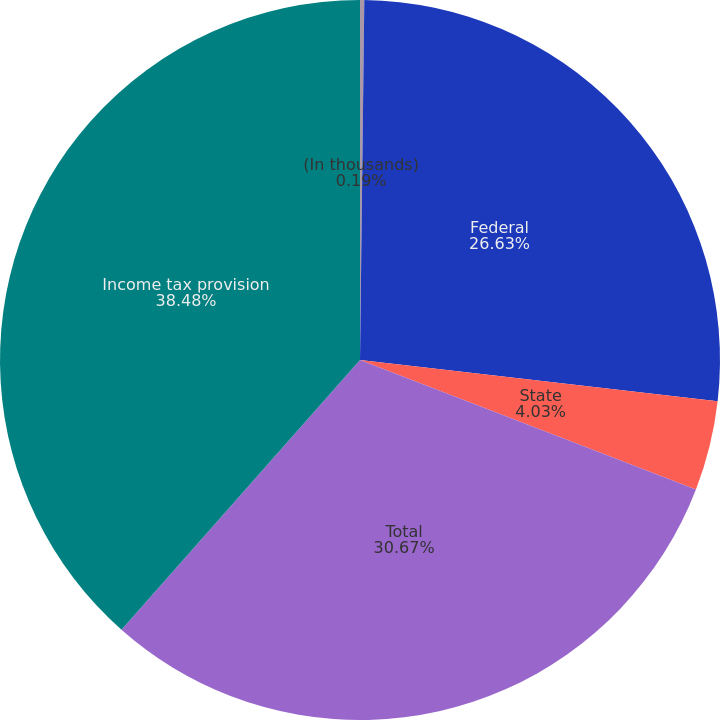Convert chart. <chart><loc_0><loc_0><loc_500><loc_500><pie_chart><fcel>(In thousands)<fcel>Federal<fcel>State<fcel>Total<fcel>Income tax provision<nl><fcel>0.19%<fcel>26.63%<fcel>4.03%<fcel>30.67%<fcel>38.47%<nl></chart> 